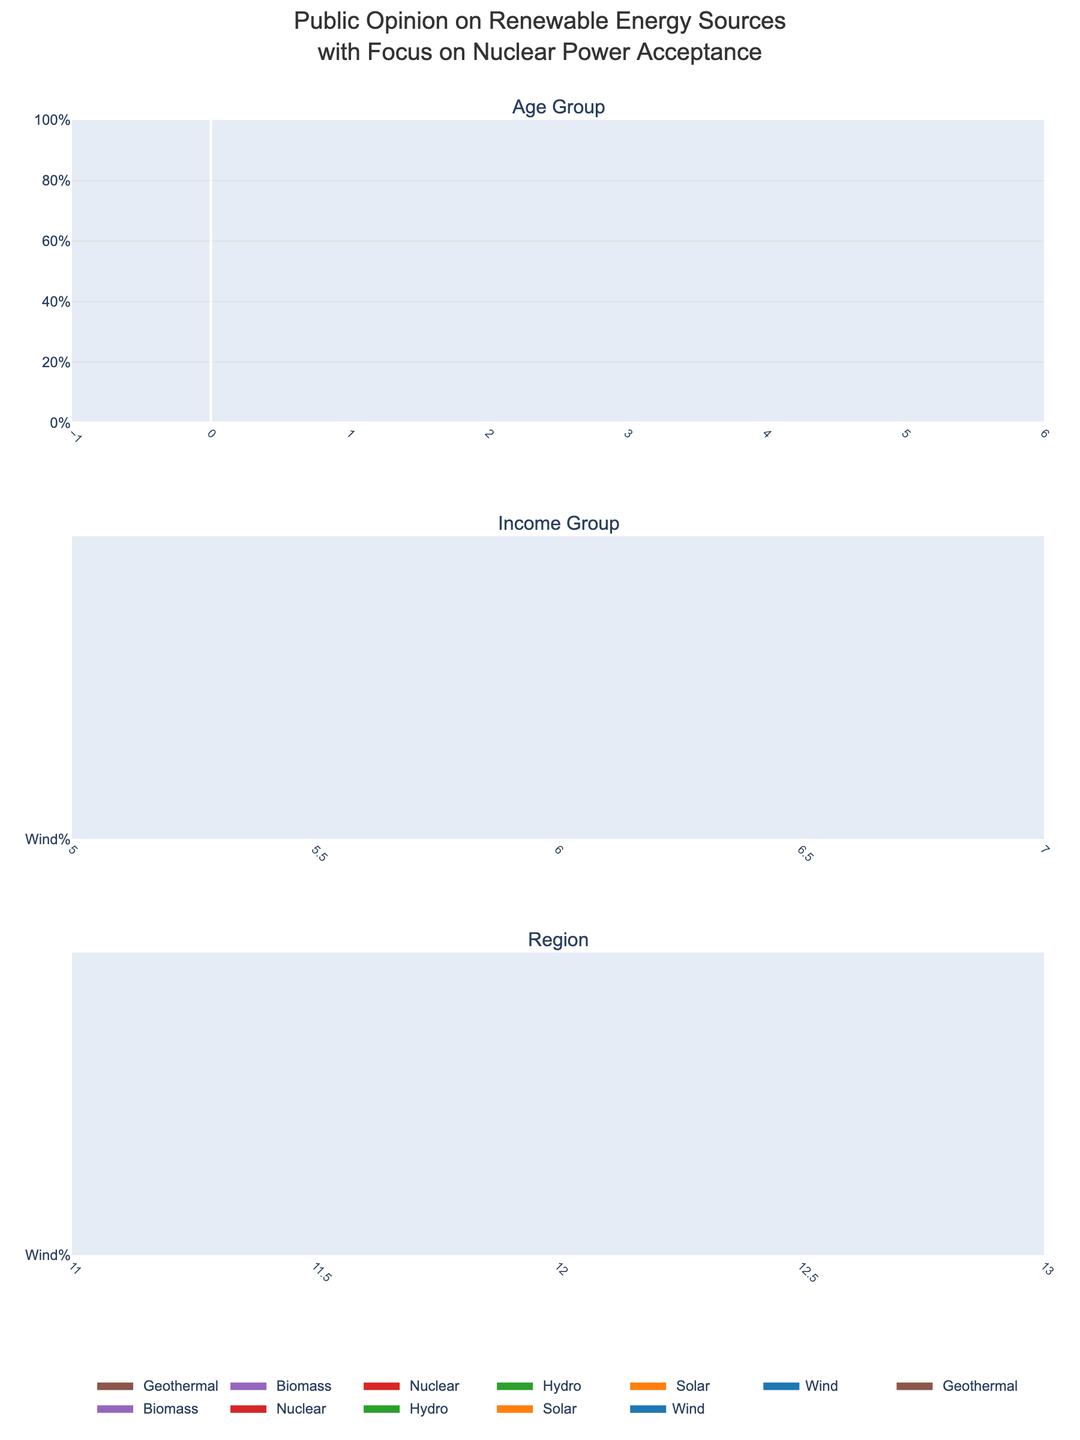What is the title of the figure? The title is usually found at the top of the figure and summarizes the content it represents.
Answer: Public Opinion on Renewable Energy Sources with Focus on Nuclear Power Acceptance Which renewable energy source has the highest acceptance among the 18–24 age group? By examining the first row of the 100% stacked area chart for the Age Group category, the segment with the highest percentage is easily identifiable.
Answer: Solar In the Income Group category, which group shows the highest acceptance of nuclear power? Look at the different colors representing nuclear power across the various income groups. The one with the largest segment represents the highest acceptance.
Answer: $100k+ How does the acceptance of nuclear power change as age increases? Observe and trace the color segment representing nuclear power (likely in red) across the different age groups to note the trend.
Answer: Nuclear power acceptance increases with age For the Midwest region, what percentage of public opinion is for wind energy? Identify the wind segment in the Midwest category and read the percentage from the 100% stacked area chart.
Answer: 18% Compare the acceptance of hydro energy between the $50k–$75k income group and the $75k–$100k income group. Which is higher? Find the hydro segment in both income groups and compare their sizes to determine the higher one.
Answer: $50k–$75k income group What stands out about geothermal energy acceptance in the Northeast region, based on the visual data? Geothermal energy is typically a small segment. Observe the segment's size and position compared to other energy sources in the Northeast region.
Answer: Geothermal energy has very low acceptance Which region shows the least interest in nuclear power? Through comparison of nuclear power segments across the different regions, the smallest segment indicates the least interest.
Answer: West Summarize the patterns of acceptance for nuclear power by demographic groups. Look at the nuclear segment across all demographic categories and note the trends or patterns for nuclear power acceptance. This will involve observing if it increases or decreases based on age, income, or region.
Answer: Acceptance of nuclear power generally increases with age and income, with the highest acceptance in older age groups and higher income brackets. The Midwest shows moderate acceptance while the Northeast and West show lesser acceptance 